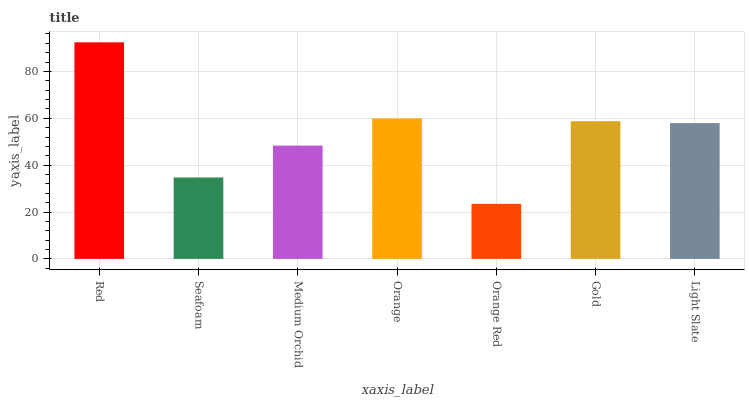Is Seafoam the minimum?
Answer yes or no. No. Is Seafoam the maximum?
Answer yes or no. No. Is Red greater than Seafoam?
Answer yes or no. Yes. Is Seafoam less than Red?
Answer yes or no. Yes. Is Seafoam greater than Red?
Answer yes or no. No. Is Red less than Seafoam?
Answer yes or no. No. Is Light Slate the high median?
Answer yes or no. Yes. Is Light Slate the low median?
Answer yes or no. Yes. Is Orange the high median?
Answer yes or no. No. Is Orange Red the low median?
Answer yes or no. No. 